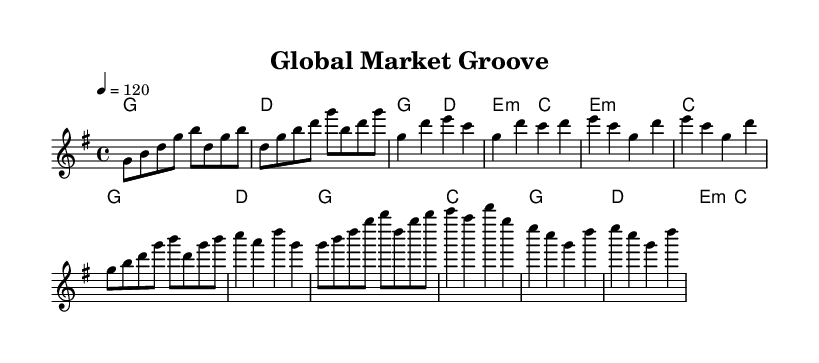what is the key signature of this music? The key signature is G major, which contains one sharp (F#). This can be determined by looking at the key signature indicated at the beginning of the staff.
Answer: G major what is the time signature of this music? The time signature is 4/4, which means there are four beats per measure and the quarter note receives one beat. This is noted at the beginning of the score.
Answer: 4/4 what is the tempo of this music? The tempo is 120 beats per minute, indicated at the beginning of the score. It suggests a lively pace for the performance.
Answer: 120 how many measures are in the chorus section? The chorus section consists of four measures, which can be counted from the notation presented, corresponding to the two repetitions of the chorus theme.
Answer: 4 what is the structure highlighted in the sheet music? The structure includes an Intro, Verse 1, Pre-Chorus, Chorus, and Bridge. This is organized sequentially and is common in K-Pop songs for maintaining listener interest.
Answer: Intro, Verse 1, Pre-Chorus, Chorus, Bridge which chords are used in the chorus? The chords used in the chorus are G and C, followed by G and D. This pattern can be identified by observing the chord symbols above the corresponding measures in the chorus section.
Answer: G, C, G, D what economic theme can you infer from the musical arrangement? The arrangement suggests a global market influence, as evidenced by the collaborative nature of K-Pop which incorporates various musical styles and artists, reflecting a blend of cultural and economic interactions.
Answer: Global market influence 